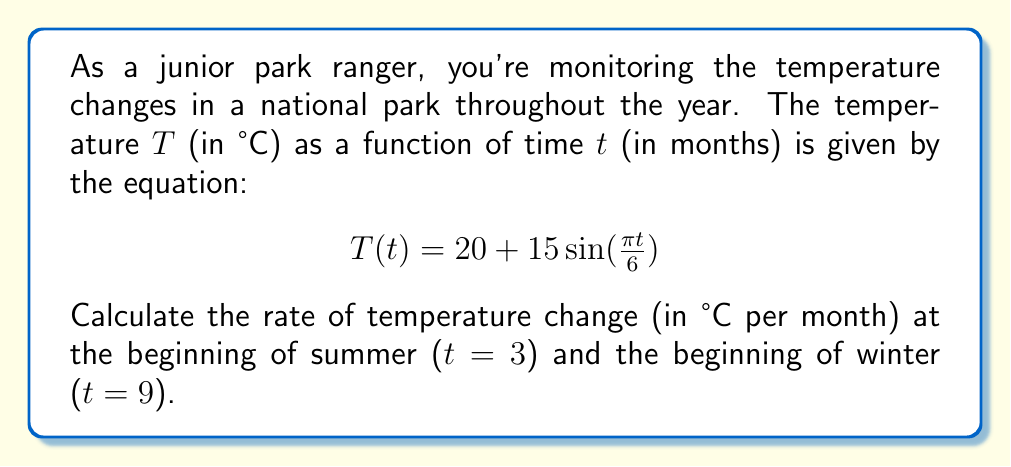Give your solution to this math problem. To find the rate of temperature change, we need to calculate the derivative of the temperature function $T(t)$ with respect to time $t$.

Step 1: Calculate the derivative of $T(t)$.
$$\frac{dT}{dt} = \frac{d}{dt}[20 + 15\sin(\frac{\pi t}{6})]$$
$$\frac{dT}{dt} = 15 \cdot \frac{\pi}{6} \cos(\frac{\pi t}{6})$$
$$\frac{dT}{dt} = \frac{5\pi}{2} \cos(\frac{\pi t}{6})$$

Step 2: Calculate the rate of change at the beginning of summer (t = 3).
$$\frac{dT}{dt}|_{t=3} = \frac{5\pi}{2} \cos(\frac{\pi \cdot 3}{6})$$
$$= \frac{5\pi}{2} \cos(\frac{\pi}{2}) = 0$$

Step 3: Calculate the rate of change at the beginning of winter (t = 9).
$$\frac{dT}{dt}|_{t=9} = \frac{5\pi}{2} \cos(\frac{\pi \cdot 9}{6})$$
$$= \frac{5\pi}{2} \cos(\frac{3\pi}{2}) = 0$$

The rate of temperature change at both the beginning of summer and winter is 0°C per month, indicating that these are turning points in the temperature cycle.
Answer: 0°C/month for both summer and winter 